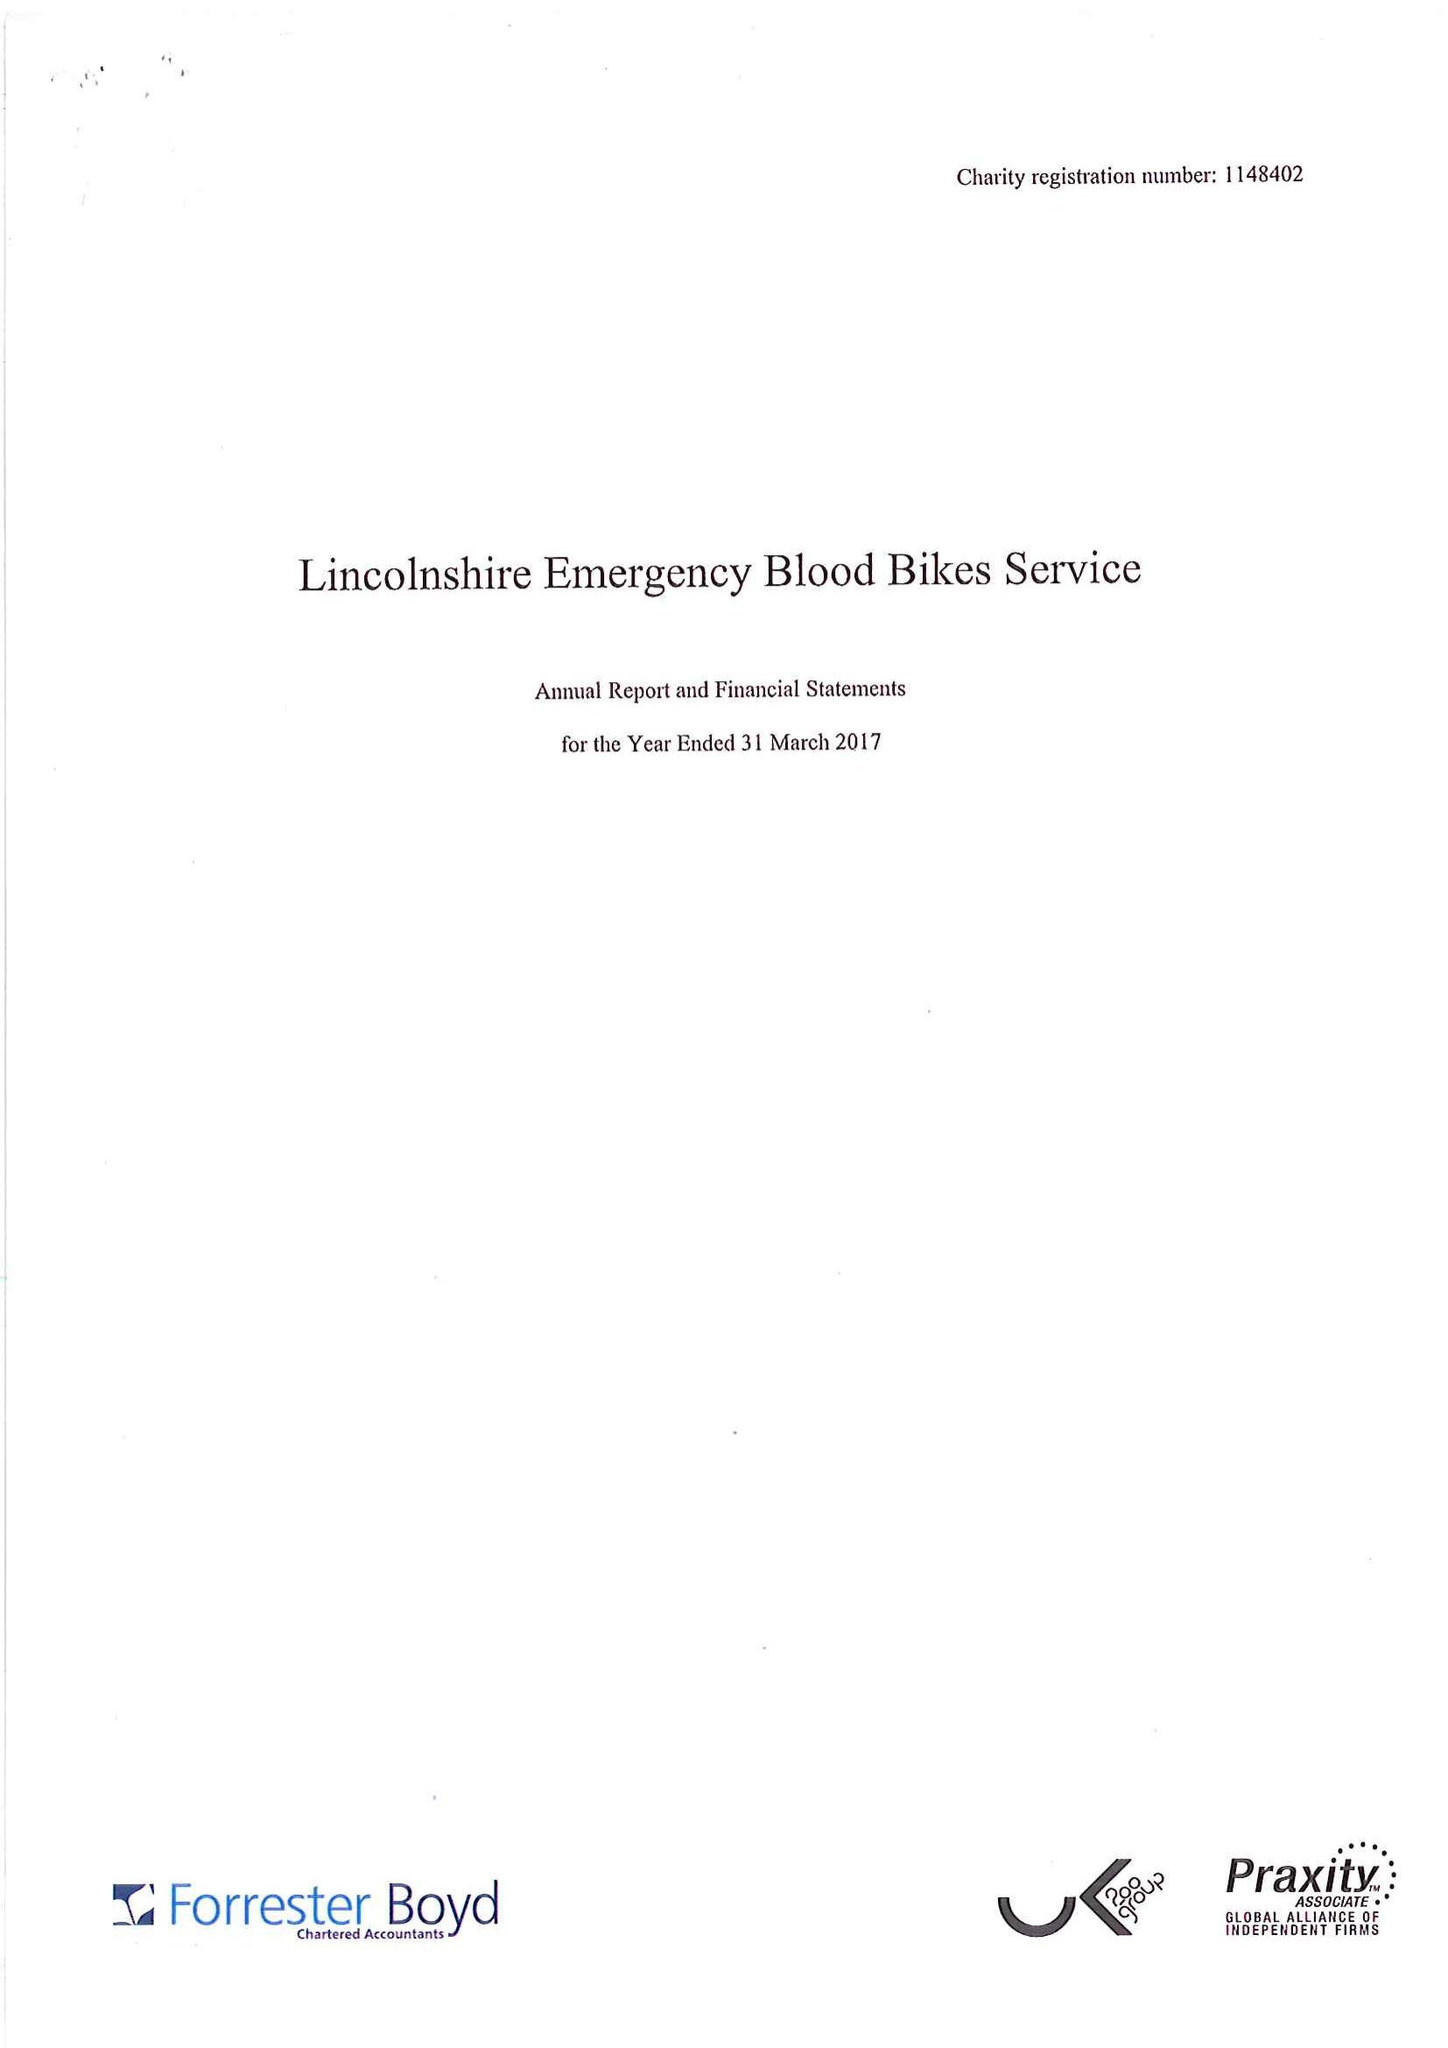What is the value for the report_date?
Answer the question using a single word or phrase. 2017-03-31 